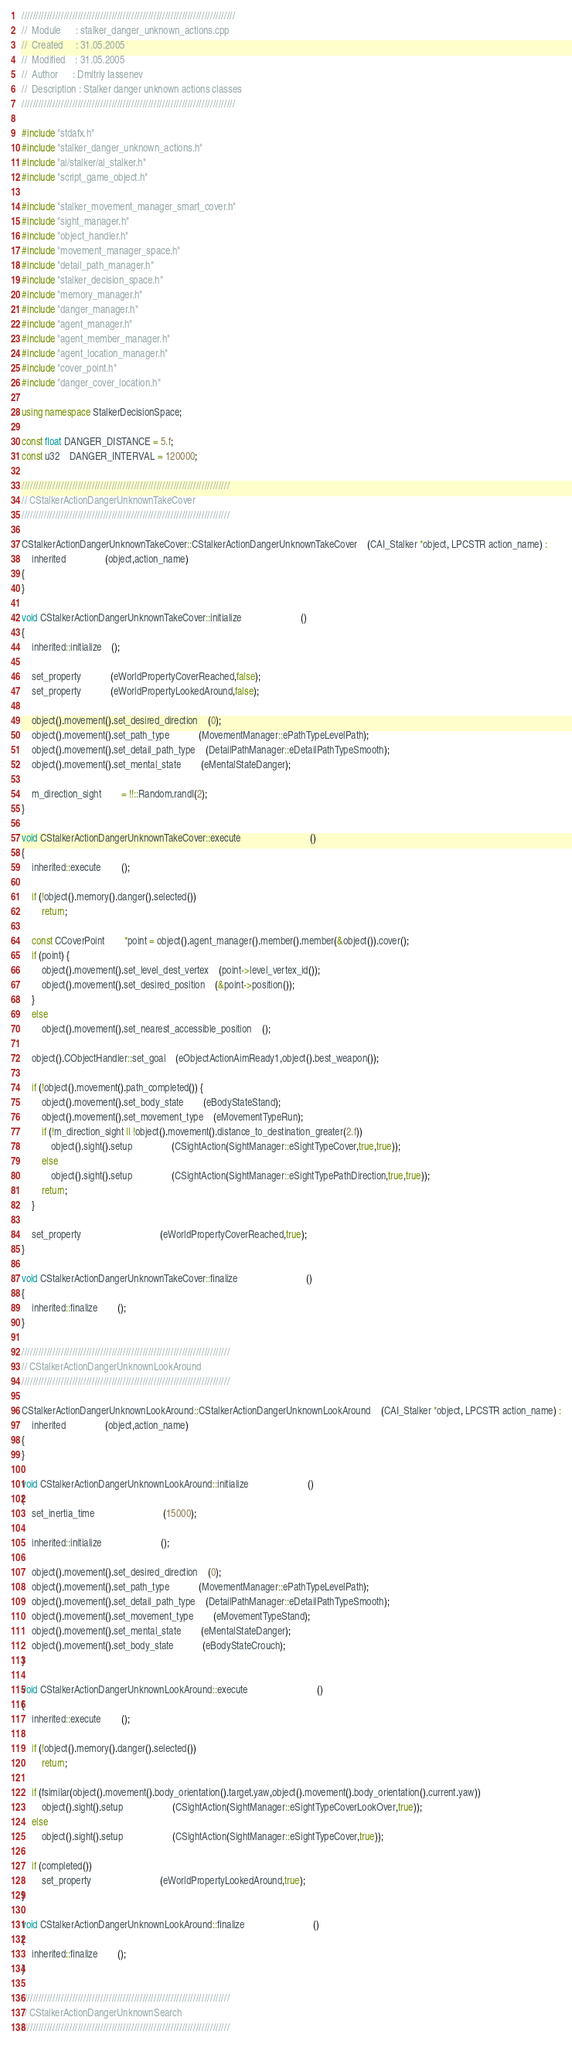<code> <loc_0><loc_0><loc_500><loc_500><_C++_>////////////////////////////////////////////////////////////////////////////
//	Module 		: stalker_danger_unknown_actions.cpp
//	Created 	: 31.05.2005
//  Modified 	: 31.05.2005
//	Author		: Dmitriy Iassenev
//	Description : Stalker danger unknown actions classes
////////////////////////////////////////////////////////////////////////////

#include "stdafx.h"
#include "stalker_danger_unknown_actions.h"
#include "ai/stalker/ai_stalker.h"
#include "script_game_object.h"

#include "stalker_movement_manager_smart_cover.h"
#include "sight_manager.h"
#include "object_handler.h"
#include "movement_manager_space.h"
#include "detail_path_manager.h"
#include "stalker_decision_space.h"
#include "memory_manager.h"
#include "danger_manager.h"
#include "agent_manager.h"
#include "agent_member_manager.h"
#include "agent_location_manager.h"
#include "cover_point.h"
#include "danger_cover_location.h"

using namespace StalkerDecisionSpace;

const float DANGER_DISTANCE = 5.f;
const u32	DANGER_INTERVAL = 120000;

//////////////////////////////////////////////////////////////////////////
// CStalkerActionDangerUnknownTakeCover
//////////////////////////////////////////////////////////////////////////

CStalkerActionDangerUnknownTakeCover::CStalkerActionDangerUnknownTakeCover	(CAI_Stalker *object, LPCSTR action_name) :
	inherited				(object,action_name)
{
}

void CStalkerActionDangerUnknownTakeCover::initialize						()
{
	inherited::initialize	();
	
	set_property			(eWorldPropertyCoverReached,false);
	set_property			(eWorldPropertyLookedAround,false);

	object().movement().set_desired_direction	(0);
	object().movement().set_path_type			(MovementManager::ePathTypeLevelPath);
	object().movement().set_detail_path_type	(DetailPathManager::eDetailPathTypeSmooth);
	object().movement().set_mental_state		(eMentalStateDanger);

	m_direction_sight		= !!::Random.randI(2);
}

void CStalkerActionDangerUnknownTakeCover::execute							()
{
	inherited::execute		();

	if (!object().memory().danger().selected())
		return;

	const CCoverPoint		*point = object().agent_manager().member().member(&object()).cover();
	if (point) {
		object().movement().set_level_dest_vertex	(point->level_vertex_id());
		object().movement().set_desired_position	(&point->position());
	}	
	else
		object().movement().set_nearest_accessible_position	();

	object().CObjectHandler::set_goal	(eObjectActionAimReady1,object().best_weapon());

	if (!object().movement().path_completed()) {
		object().movement().set_body_state		(eBodyStateStand);
		object().movement().set_movement_type	(eMovementTypeRun);
		if (!m_direction_sight || !object().movement().distance_to_destination_greater(2.f))
			object().sight().setup				(CSightAction(SightManager::eSightTypeCover,true,true));
		else
			object().sight().setup				(CSightAction(SightManager::eSightTypePathDirection,true,true));
		return;
	}

	set_property								(eWorldPropertyCoverReached,true);
}

void CStalkerActionDangerUnknownTakeCover::finalize							()
{
	inherited::finalize		();
}

//////////////////////////////////////////////////////////////////////////
// CStalkerActionDangerUnknownLookAround
//////////////////////////////////////////////////////////////////////////

CStalkerActionDangerUnknownLookAround::CStalkerActionDangerUnknownLookAround	(CAI_Stalker *object, LPCSTR action_name) :
	inherited				(object,action_name)
{
}

void CStalkerActionDangerUnknownLookAround::initialize						()
{
	set_inertia_time							(15000);

	inherited::initialize						();

	object().movement().set_desired_direction	(0);
	object().movement().set_path_type			(MovementManager::ePathTypeLevelPath);
	object().movement().set_detail_path_type	(DetailPathManager::eDetailPathTypeSmooth);
	object().movement().set_movement_type		(eMovementTypeStand);
	object().movement().set_mental_state		(eMentalStateDanger);
	object().movement().set_body_state			(eBodyStateCrouch);
}

void CStalkerActionDangerUnknownLookAround::execute							()
{
	inherited::execute		();

	if (!object().memory().danger().selected())
		return;

	if (fsimilar(object().movement().body_orientation().target.yaw,object().movement().body_orientation().current.yaw))
		object().sight().setup					(CSightAction(SightManager::eSightTypeCoverLookOver,true));
	else
		object().sight().setup					(CSightAction(SightManager::eSightTypeCover,true));

	if (completed())
		set_property							(eWorldPropertyLookedAround,true);
}

void CStalkerActionDangerUnknownLookAround::finalize							()
{
	inherited::finalize		();
}

//////////////////////////////////////////////////////////////////////////
// CStalkerActionDangerUnknownSearch
//////////////////////////////////////////////////////////////////////////
</code> 